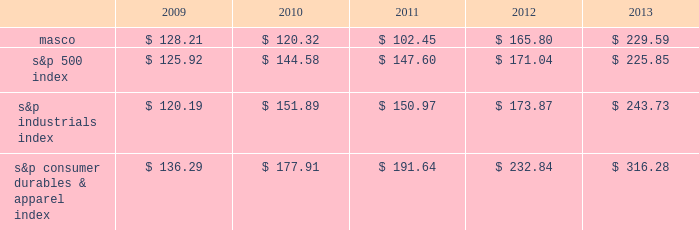6feb201418202649 performance graph the table below compares the cumulative total shareholder return on our common stock with the cumulative total return of ( i ) the standard & poor 2019s 500 composite stock index ( 2018 2018s&p 500 index 2019 2019 ) , ( ii ) the standard & poor 2019s industrials index ( 2018 2018s&p industrials index 2019 2019 ) and ( iii ) the standard & poor 2019s consumer durables & apparel index ( 2018 2018s&p consumer durables & apparel index 2019 2019 ) , from december 31 , 2008 through december 31 , 2013 , when the closing price of our common stock was $ 22.77 .
The graph assumes investments of $ 100 on december 31 , 2008 in our common stock and in each of the three indices and the reinvestment of dividends .
$ 350.00 $ 300.00 $ 250.00 $ 200.00 $ 150.00 $ 100.00 $ 50.00 performance graph .
In july 2007 , our board of directors authorized the purchase of up to 50 million shares of our common stock in open-market transactions or otherwise .
At december 31 , 2013 , we had remaining authorization to repurchase up to 22.6 million shares .
During the first quarter of 2013 , we repurchased and retired 1.7 million shares of our common stock , for cash aggregating $ 35 million to offset the dilutive impact of the 2013 grant of 1.7 million shares of long-term stock awards .
We have not purchased any shares since march 2013. .
What was the percent of the remaining authorization to repurchase of the 2007 authorized the purchase at december 2013? 
Rationale: as of december 2013 , the remaining authorization to repurchase of the 2007 authorized the purchase was 45.2%
Computations: (22.6 / 50)
Answer: 0.452. 